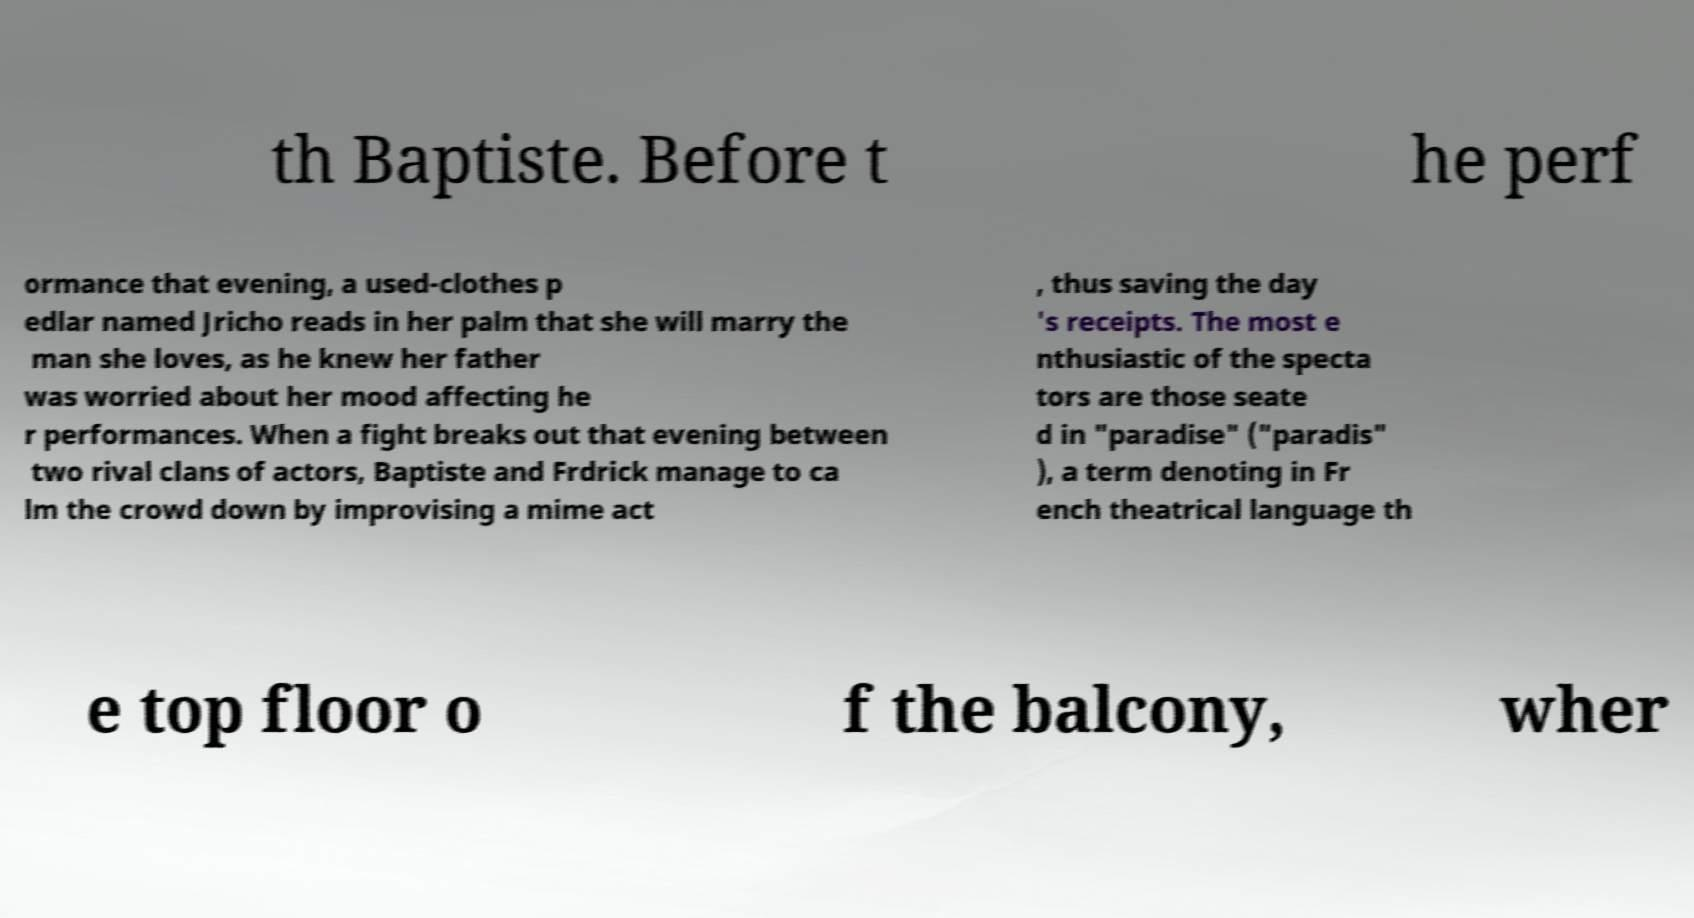Can you read and provide the text displayed in the image?This photo seems to have some interesting text. Can you extract and type it out for me? th Baptiste. Before t he perf ormance that evening, a used-clothes p edlar named Jricho reads in her palm that she will marry the man she loves, as he knew her father was worried about her mood affecting he r performances. When a fight breaks out that evening between two rival clans of actors, Baptiste and Frdrick manage to ca lm the crowd down by improvising a mime act , thus saving the day 's receipts. The most e nthusiastic of the specta tors are those seate d in "paradise" ("paradis" ), a term denoting in Fr ench theatrical language th e top floor o f the balcony, wher 